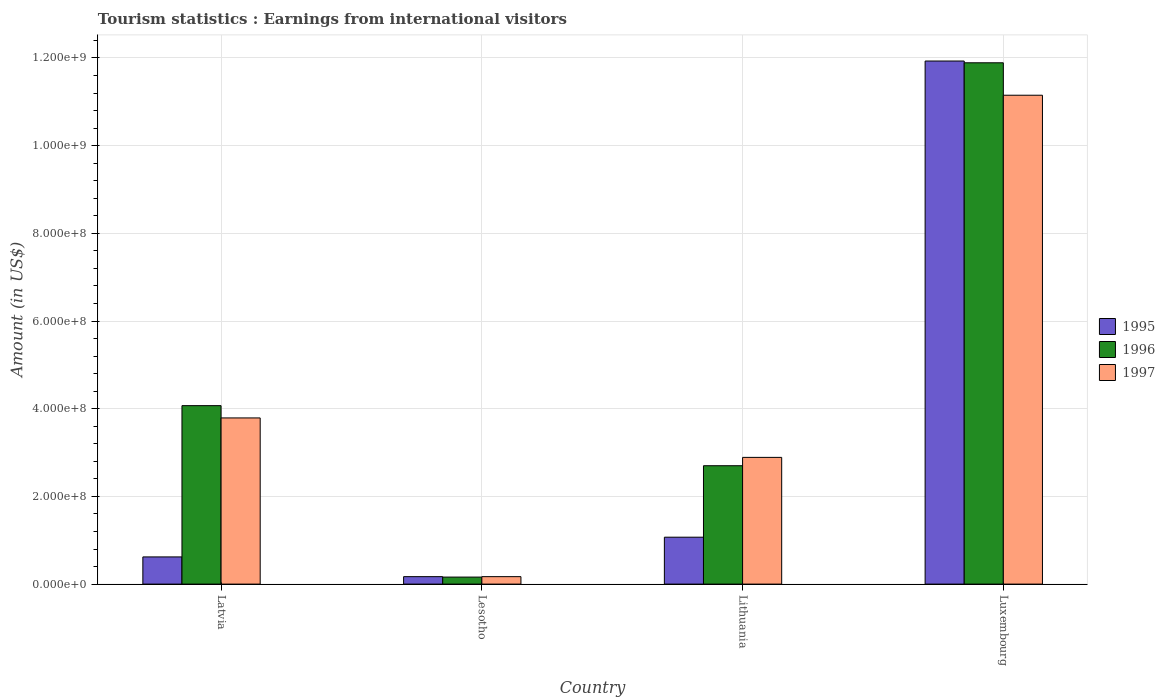How many groups of bars are there?
Provide a succinct answer. 4. Are the number of bars per tick equal to the number of legend labels?
Your answer should be compact. Yes. Are the number of bars on each tick of the X-axis equal?
Keep it short and to the point. Yes. How many bars are there on the 3rd tick from the left?
Ensure brevity in your answer.  3. What is the label of the 3rd group of bars from the left?
Provide a succinct answer. Lithuania. What is the earnings from international visitors in 1997 in Lithuania?
Your answer should be compact. 2.89e+08. Across all countries, what is the maximum earnings from international visitors in 1997?
Provide a short and direct response. 1.12e+09. Across all countries, what is the minimum earnings from international visitors in 1997?
Ensure brevity in your answer.  1.70e+07. In which country was the earnings from international visitors in 1997 maximum?
Keep it short and to the point. Luxembourg. In which country was the earnings from international visitors in 1996 minimum?
Keep it short and to the point. Lesotho. What is the total earnings from international visitors in 1996 in the graph?
Offer a terse response. 1.88e+09. What is the difference between the earnings from international visitors in 1995 in Latvia and that in Lesotho?
Give a very brief answer. 4.50e+07. What is the difference between the earnings from international visitors in 1996 in Latvia and the earnings from international visitors in 1995 in Lithuania?
Offer a very short reply. 3.00e+08. What is the average earnings from international visitors in 1996 per country?
Your answer should be very brief. 4.70e+08. What is the ratio of the earnings from international visitors in 1996 in Latvia to that in Lesotho?
Keep it short and to the point. 25.44. Is the earnings from international visitors in 1997 in Latvia less than that in Lithuania?
Offer a terse response. No. What is the difference between the highest and the second highest earnings from international visitors in 1995?
Ensure brevity in your answer.  1.13e+09. What is the difference between the highest and the lowest earnings from international visitors in 1995?
Provide a short and direct response. 1.18e+09. In how many countries, is the earnings from international visitors in 1996 greater than the average earnings from international visitors in 1996 taken over all countries?
Offer a terse response. 1. What does the 1st bar from the left in Lithuania represents?
Provide a short and direct response. 1995. What does the 1st bar from the right in Luxembourg represents?
Ensure brevity in your answer.  1997. Is it the case that in every country, the sum of the earnings from international visitors in 1997 and earnings from international visitors in 1996 is greater than the earnings from international visitors in 1995?
Keep it short and to the point. Yes. How many bars are there?
Your response must be concise. 12. How many countries are there in the graph?
Provide a short and direct response. 4. Does the graph contain grids?
Offer a terse response. Yes. Where does the legend appear in the graph?
Provide a succinct answer. Center right. How many legend labels are there?
Provide a short and direct response. 3. What is the title of the graph?
Make the answer very short. Tourism statistics : Earnings from international visitors. Does "2007" appear as one of the legend labels in the graph?
Ensure brevity in your answer.  No. What is the label or title of the X-axis?
Offer a very short reply. Country. What is the label or title of the Y-axis?
Provide a short and direct response. Amount (in US$). What is the Amount (in US$) of 1995 in Latvia?
Ensure brevity in your answer.  6.20e+07. What is the Amount (in US$) in 1996 in Latvia?
Keep it short and to the point. 4.07e+08. What is the Amount (in US$) in 1997 in Latvia?
Your response must be concise. 3.79e+08. What is the Amount (in US$) of 1995 in Lesotho?
Your response must be concise. 1.70e+07. What is the Amount (in US$) in 1996 in Lesotho?
Make the answer very short. 1.60e+07. What is the Amount (in US$) of 1997 in Lesotho?
Your answer should be very brief. 1.70e+07. What is the Amount (in US$) of 1995 in Lithuania?
Your answer should be compact. 1.07e+08. What is the Amount (in US$) in 1996 in Lithuania?
Make the answer very short. 2.70e+08. What is the Amount (in US$) in 1997 in Lithuania?
Give a very brief answer. 2.89e+08. What is the Amount (in US$) in 1995 in Luxembourg?
Your answer should be very brief. 1.19e+09. What is the Amount (in US$) of 1996 in Luxembourg?
Provide a succinct answer. 1.19e+09. What is the Amount (in US$) in 1997 in Luxembourg?
Provide a succinct answer. 1.12e+09. Across all countries, what is the maximum Amount (in US$) in 1995?
Ensure brevity in your answer.  1.19e+09. Across all countries, what is the maximum Amount (in US$) of 1996?
Provide a short and direct response. 1.19e+09. Across all countries, what is the maximum Amount (in US$) in 1997?
Your answer should be very brief. 1.12e+09. Across all countries, what is the minimum Amount (in US$) of 1995?
Offer a very short reply. 1.70e+07. Across all countries, what is the minimum Amount (in US$) in 1996?
Your answer should be very brief. 1.60e+07. Across all countries, what is the minimum Amount (in US$) in 1997?
Keep it short and to the point. 1.70e+07. What is the total Amount (in US$) in 1995 in the graph?
Give a very brief answer. 1.38e+09. What is the total Amount (in US$) in 1996 in the graph?
Offer a terse response. 1.88e+09. What is the total Amount (in US$) of 1997 in the graph?
Ensure brevity in your answer.  1.80e+09. What is the difference between the Amount (in US$) of 1995 in Latvia and that in Lesotho?
Offer a terse response. 4.50e+07. What is the difference between the Amount (in US$) of 1996 in Latvia and that in Lesotho?
Your answer should be very brief. 3.91e+08. What is the difference between the Amount (in US$) in 1997 in Latvia and that in Lesotho?
Your answer should be compact. 3.62e+08. What is the difference between the Amount (in US$) in 1995 in Latvia and that in Lithuania?
Offer a very short reply. -4.50e+07. What is the difference between the Amount (in US$) in 1996 in Latvia and that in Lithuania?
Offer a terse response. 1.37e+08. What is the difference between the Amount (in US$) of 1997 in Latvia and that in Lithuania?
Offer a terse response. 9.00e+07. What is the difference between the Amount (in US$) in 1995 in Latvia and that in Luxembourg?
Keep it short and to the point. -1.13e+09. What is the difference between the Amount (in US$) of 1996 in Latvia and that in Luxembourg?
Offer a very short reply. -7.82e+08. What is the difference between the Amount (in US$) in 1997 in Latvia and that in Luxembourg?
Offer a terse response. -7.36e+08. What is the difference between the Amount (in US$) in 1995 in Lesotho and that in Lithuania?
Provide a succinct answer. -9.00e+07. What is the difference between the Amount (in US$) in 1996 in Lesotho and that in Lithuania?
Provide a short and direct response. -2.54e+08. What is the difference between the Amount (in US$) of 1997 in Lesotho and that in Lithuania?
Offer a terse response. -2.72e+08. What is the difference between the Amount (in US$) of 1995 in Lesotho and that in Luxembourg?
Keep it short and to the point. -1.18e+09. What is the difference between the Amount (in US$) in 1996 in Lesotho and that in Luxembourg?
Your answer should be very brief. -1.17e+09. What is the difference between the Amount (in US$) of 1997 in Lesotho and that in Luxembourg?
Ensure brevity in your answer.  -1.10e+09. What is the difference between the Amount (in US$) of 1995 in Lithuania and that in Luxembourg?
Make the answer very short. -1.09e+09. What is the difference between the Amount (in US$) of 1996 in Lithuania and that in Luxembourg?
Your answer should be very brief. -9.19e+08. What is the difference between the Amount (in US$) of 1997 in Lithuania and that in Luxembourg?
Keep it short and to the point. -8.26e+08. What is the difference between the Amount (in US$) in 1995 in Latvia and the Amount (in US$) in 1996 in Lesotho?
Keep it short and to the point. 4.60e+07. What is the difference between the Amount (in US$) in 1995 in Latvia and the Amount (in US$) in 1997 in Lesotho?
Ensure brevity in your answer.  4.50e+07. What is the difference between the Amount (in US$) of 1996 in Latvia and the Amount (in US$) of 1997 in Lesotho?
Offer a very short reply. 3.90e+08. What is the difference between the Amount (in US$) in 1995 in Latvia and the Amount (in US$) in 1996 in Lithuania?
Make the answer very short. -2.08e+08. What is the difference between the Amount (in US$) of 1995 in Latvia and the Amount (in US$) of 1997 in Lithuania?
Make the answer very short. -2.27e+08. What is the difference between the Amount (in US$) of 1996 in Latvia and the Amount (in US$) of 1997 in Lithuania?
Your answer should be compact. 1.18e+08. What is the difference between the Amount (in US$) in 1995 in Latvia and the Amount (in US$) in 1996 in Luxembourg?
Offer a terse response. -1.13e+09. What is the difference between the Amount (in US$) of 1995 in Latvia and the Amount (in US$) of 1997 in Luxembourg?
Provide a short and direct response. -1.05e+09. What is the difference between the Amount (in US$) of 1996 in Latvia and the Amount (in US$) of 1997 in Luxembourg?
Your answer should be compact. -7.08e+08. What is the difference between the Amount (in US$) in 1995 in Lesotho and the Amount (in US$) in 1996 in Lithuania?
Provide a short and direct response. -2.53e+08. What is the difference between the Amount (in US$) in 1995 in Lesotho and the Amount (in US$) in 1997 in Lithuania?
Your response must be concise. -2.72e+08. What is the difference between the Amount (in US$) in 1996 in Lesotho and the Amount (in US$) in 1997 in Lithuania?
Your answer should be very brief. -2.73e+08. What is the difference between the Amount (in US$) of 1995 in Lesotho and the Amount (in US$) of 1996 in Luxembourg?
Your answer should be very brief. -1.17e+09. What is the difference between the Amount (in US$) in 1995 in Lesotho and the Amount (in US$) in 1997 in Luxembourg?
Provide a short and direct response. -1.10e+09. What is the difference between the Amount (in US$) of 1996 in Lesotho and the Amount (in US$) of 1997 in Luxembourg?
Provide a succinct answer. -1.10e+09. What is the difference between the Amount (in US$) in 1995 in Lithuania and the Amount (in US$) in 1996 in Luxembourg?
Provide a succinct answer. -1.08e+09. What is the difference between the Amount (in US$) of 1995 in Lithuania and the Amount (in US$) of 1997 in Luxembourg?
Provide a succinct answer. -1.01e+09. What is the difference between the Amount (in US$) of 1996 in Lithuania and the Amount (in US$) of 1997 in Luxembourg?
Your response must be concise. -8.45e+08. What is the average Amount (in US$) in 1995 per country?
Give a very brief answer. 3.45e+08. What is the average Amount (in US$) of 1996 per country?
Provide a succinct answer. 4.70e+08. What is the average Amount (in US$) in 1997 per country?
Give a very brief answer. 4.50e+08. What is the difference between the Amount (in US$) of 1995 and Amount (in US$) of 1996 in Latvia?
Give a very brief answer. -3.45e+08. What is the difference between the Amount (in US$) in 1995 and Amount (in US$) in 1997 in Latvia?
Provide a short and direct response. -3.17e+08. What is the difference between the Amount (in US$) in 1996 and Amount (in US$) in 1997 in Latvia?
Offer a very short reply. 2.80e+07. What is the difference between the Amount (in US$) in 1995 and Amount (in US$) in 1997 in Lesotho?
Provide a succinct answer. 0. What is the difference between the Amount (in US$) in 1996 and Amount (in US$) in 1997 in Lesotho?
Offer a very short reply. -1.00e+06. What is the difference between the Amount (in US$) in 1995 and Amount (in US$) in 1996 in Lithuania?
Keep it short and to the point. -1.63e+08. What is the difference between the Amount (in US$) in 1995 and Amount (in US$) in 1997 in Lithuania?
Offer a terse response. -1.82e+08. What is the difference between the Amount (in US$) in 1996 and Amount (in US$) in 1997 in Lithuania?
Keep it short and to the point. -1.90e+07. What is the difference between the Amount (in US$) of 1995 and Amount (in US$) of 1997 in Luxembourg?
Provide a short and direct response. 7.80e+07. What is the difference between the Amount (in US$) in 1996 and Amount (in US$) in 1997 in Luxembourg?
Your response must be concise. 7.40e+07. What is the ratio of the Amount (in US$) of 1995 in Latvia to that in Lesotho?
Ensure brevity in your answer.  3.65. What is the ratio of the Amount (in US$) of 1996 in Latvia to that in Lesotho?
Make the answer very short. 25.44. What is the ratio of the Amount (in US$) in 1997 in Latvia to that in Lesotho?
Give a very brief answer. 22.29. What is the ratio of the Amount (in US$) in 1995 in Latvia to that in Lithuania?
Offer a very short reply. 0.58. What is the ratio of the Amount (in US$) in 1996 in Latvia to that in Lithuania?
Your response must be concise. 1.51. What is the ratio of the Amount (in US$) in 1997 in Latvia to that in Lithuania?
Ensure brevity in your answer.  1.31. What is the ratio of the Amount (in US$) in 1995 in Latvia to that in Luxembourg?
Your response must be concise. 0.05. What is the ratio of the Amount (in US$) in 1996 in Latvia to that in Luxembourg?
Offer a terse response. 0.34. What is the ratio of the Amount (in US$) of 1997 in Latvia to that in Luxembourg?
Your answer should be compact. 0.34. What is the ratio of the Amount (in US$) of 1995 in Lesotho to that in Lithuania?
Offer a terse response. 0.16. What is the ratio of the Amount (in US$) of 1996 in Lesotho to that in Lithuania?
Offer a terse response. 0.06. What is the ratio of the Amount (in US$) of 1997 in Lesotho to that in Lithuania?
Make the answer very short. 0.06. What is the ratio of the Amount (in US$) of 1995 in Lesotho to that in Luxembourg?
Ensure brevity in your answer.  0.01. What is the ratio of the Amount (in US$) in 1996 in Lesotho to that in Luxembourg?
Keep it short and to the point. 0.01. What is the ratio of the Amount (in US$) in 1997 in Lesotho to that in Luxembourg?
Your answer should be compact. 0.02. What is the ratio of the Amount (in US$) of 1995 in Lithuania to that in Luxembourg?
Make the answer very short. 0.09. What is the ratio of the Amount (in US$) in 1996 in Lithuania to that in Luxembourg?
Provide a short and direct response. 0.23. What is the ratio of the Amount (in US$) in 1997 in Lithuania to that in Luxembourg?
Give a very brief answer. 0.26. What is the difference between the highest and the second highest Amount (in US$) in 1995?
Ensure brevity in your answer.  1.09e+09. What is the difference between the highest and the second highest Amount (in US$) of 1996?
Your answer should be very brief. 7.82e+08. What is the difference between the highest and the second highest Amount (in US$) in 1997?
Your answer should be very brief. 7.36e+08. What is the difference between the highest and the lowest Amount (in US$) in 1995?
Give a very brief answer. 1.18e+09. What is the difference between the highest and the lowest Amount (in US$) of 1996?
Offer a terse response. 1.17e+09. What is the difference between the highest and the lowest Amount (in US$) in 1997?
Make the answer very short. 1.10e+09. 